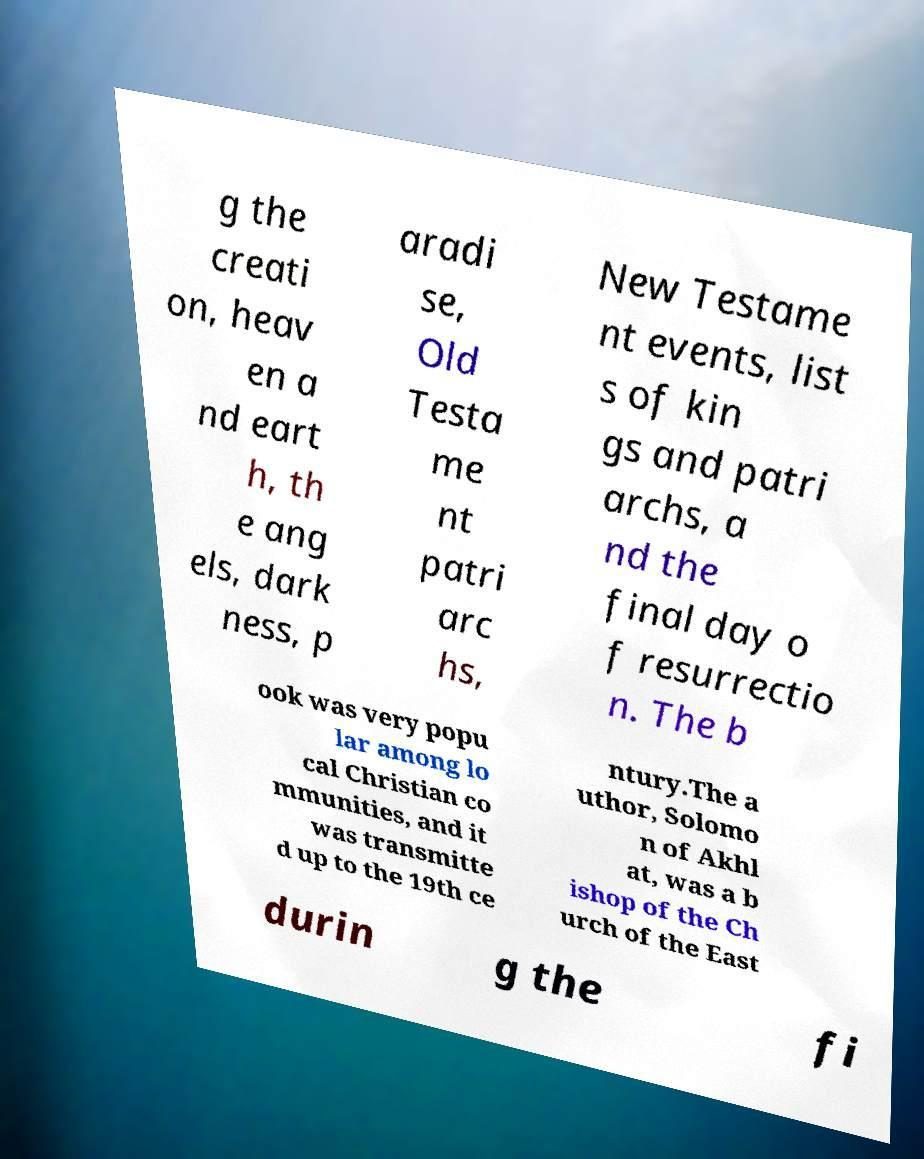I need the written content from this picture converted into text. Can you do that? g the creati on, heav en a nd eart h, th e ang els, dark ness, p aradi se, Old Testa me nt patri arc hs, New Testame nt events, list s of kin gs and patri archs, a nd the final day o f resurrectio n. The b ook was very popu lar among lo cal Christian co mmunities, and it was transmitte d up to the 19th ce ntury.The a uthor, Solomo n of Akhl at, was a b ishop of the Ch urch of the East durin g the fi 